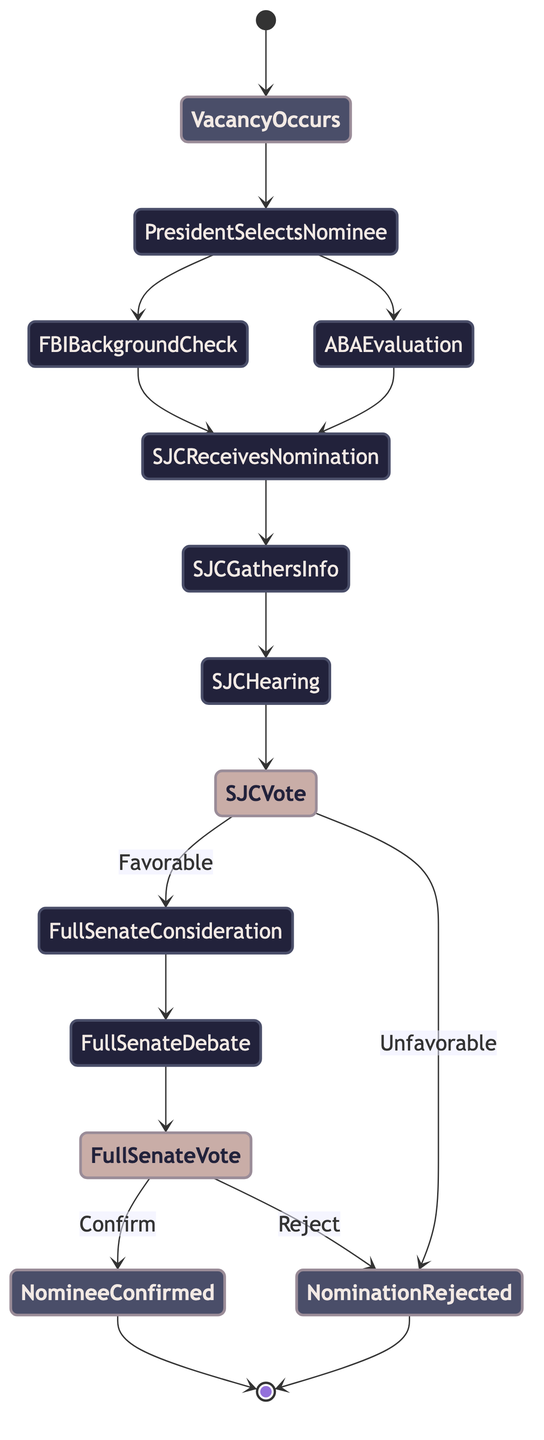What is the starting point of the process? The starting point, or the first event in the diagram, is labeled "Vacancy Occurs." This indicates where the entire nomination and confirmation process begins.
Answer: Vacancy Occurs How many decision points are there in this diagram? There are two decision points in the diagram: one after the Senate Judiciary Committee Vote and another after the Full Senate Vote. Each decision point results in two possible outcomes.
Answer: 2 What happens if the Senate Judiciary Committee vote is unfavorable? If the vote is unfavorable, the process moves to the "Nomination Rejected" node, indicating the end of that nomination attempt.
Answer: Nomination Rejected What action follows the "Full Senate Debate"? After the "Full Senate Debate," the next action is "Full Senate Vote," which is pivotal for the confirmation of the nominee.
Answer: Full Senate Vote What is the final outcome if the Full Senate Vote confirms the nominee? The final outcome, if the nominee is confirmed by the Full Senate Vote, is "Nominee Confirmed." This marks the successful conclusion of the nomination process.
Answer: Nominee Confirmed What two actions must take place before the Senate Judiciary Committee receives the nomination? The two actions that must occur before the Senate Judiciary Committee receives the nomination are "FBI Background Check" and "American Bar Association Evaluation." Both actions happen simultaneously before the nomination is sent to the committee.
Answer: FBI Background Check and American Bar Association Evaluation What is the relationship between "Senate Judiciary Committee Hearing" and "Senate Judiciary Committee Vote"? The "Senate Judiciary Committee Hearing" directly precedes the "Senate Judiciary Committee Vote," indicating that the hearing is conducted first before any voting occurs on the nominee.
Answer: Precedes What results in a "Nominee Confirmed"? A "Nominee Confirmed" occurs if the "Full Senate Vote" results in a "Confirm" outcome, completing the process positively for the nominee.
Answer: Full Senate Vote: Confirm What action occurs after "Senate Judiciary Committee Gathers Information"? After "Senate Judiciary Committee Gathers Information," the next action is "Senate Judiciary Committee Hearing," where the gathered information is deliberated upon.
Answer: Senate Judiciary Committee Hearing 